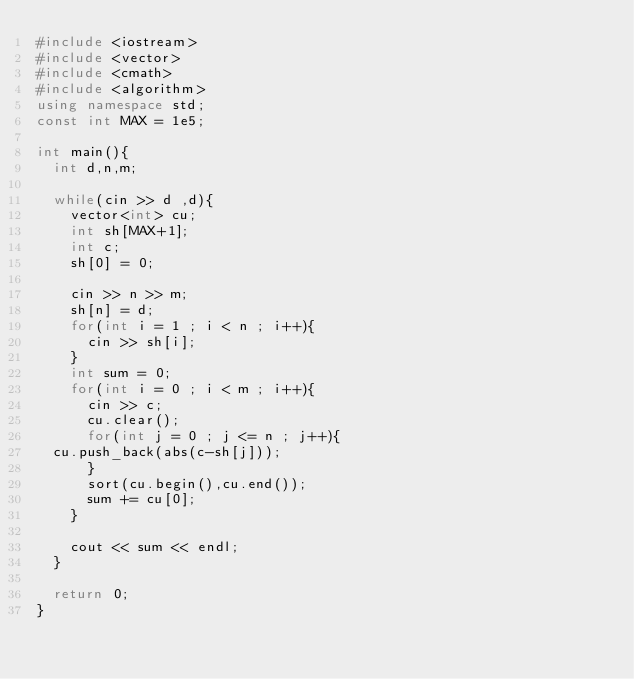Convert code to text. <code><loc_0><loc_0><loc_500><loc_500><_C++_>#include <iostream>
#include <vector>
#include <cmath>
#include <algorithm>
using namespace std;
const int MAX = 1e5;

int main(){
  int d,n,m;

  while(cin >> d ,d){
    vector<int> cu;
    int sh[MAX+1];
    int c;
    sh[0] = 0;

    cin >> n >> m;
    sh[n] = d;
    for(int i = 1 ; i < n ; i++){
      cin >> sh[i];
    }
    int sum = 0;
    for(int i = 0 ; i < m ; i++){
      cin >> c;
      cu.clear();
      for(int j = 0 ; j <= n ; j++){
	cu.push_back(abs(c-sh[j]));
      }
      sort(cu.begin(),cu.end());
      sum += cu[0];
    }
  
    cout << sum << endl;
  }

  return 0;
}</code> 